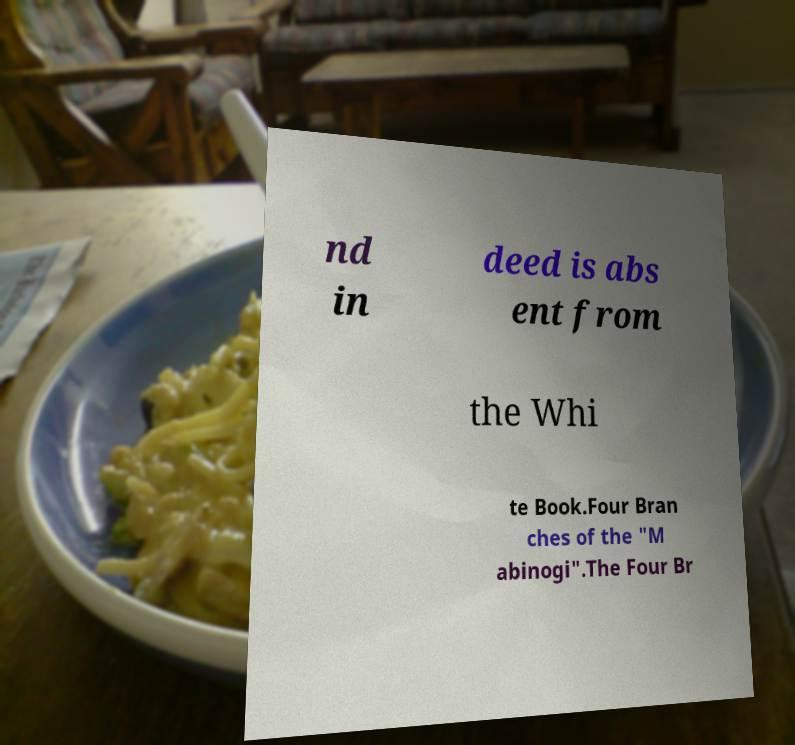Can you read and provide the text displayed in the image?This photo seems to have some interesting text. Can you extract and type it out for me? nd in deed is abs ent from the Whi te Book.Four Bran ches of the "M abinogi".The Four Br 